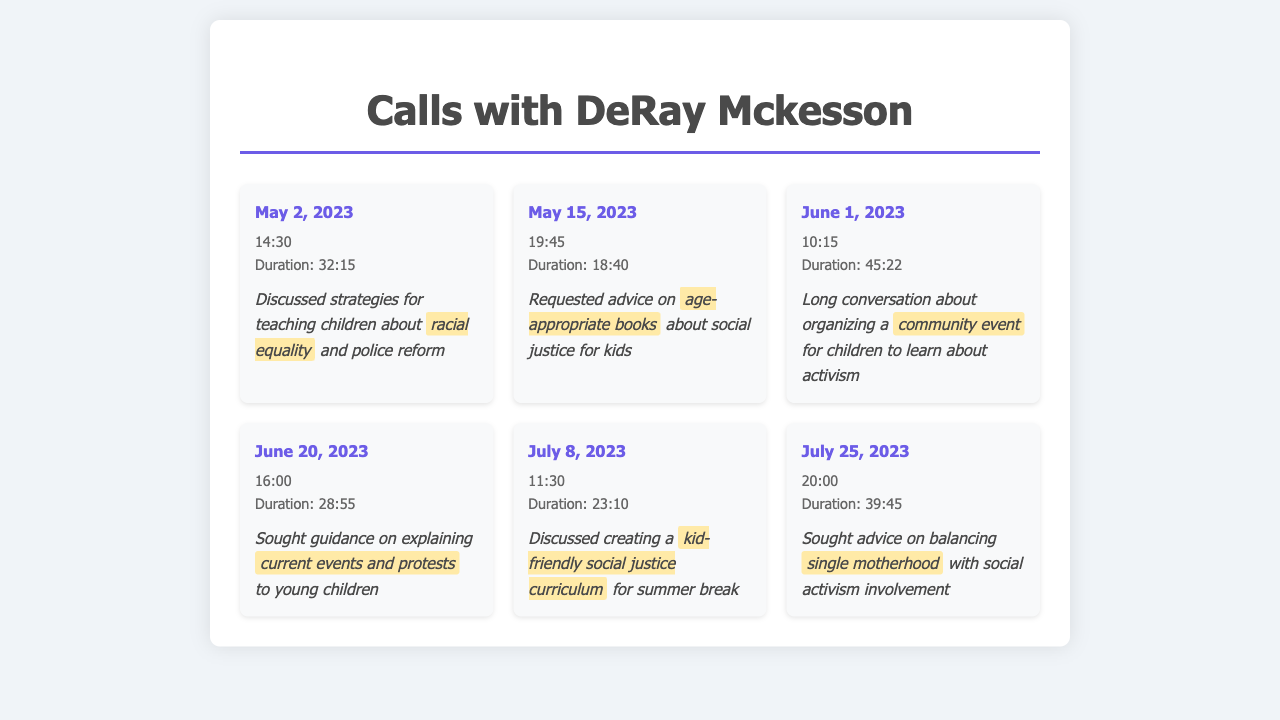What is the longest call duration? The longest call duration can be found in the entries and is 45:22.
Answer: 45:22 When did the first call take place? The first call date in the log is May 2, 2023.
Answer: May 2, 2023 What topic was discussed during the call on June 20, 2023? The notes for the call on that date mention explaining current events and protests.
Answer: current events and protests How many calls were made in July 2023? The document lists two calls made in July 2023.
Answer: 2 What was requested in the call on May 15, 2023? The notes indicate that age-appropriate books about social justice were requested.
Answer: age-appropriate books What was the call duration on July 25, 2023? The duration of the call on that date is listed as 39:45.
Answer: 39:45 What is the main theme of the discussed topics? The notes repeatedly refer to teaching children about various aspects of social justice.
Answer: social justice What is a topic of concern mentioned by the single mother? The call notes indicate a concern about balancing single motherhood with activism.
Answer: single motherhood 